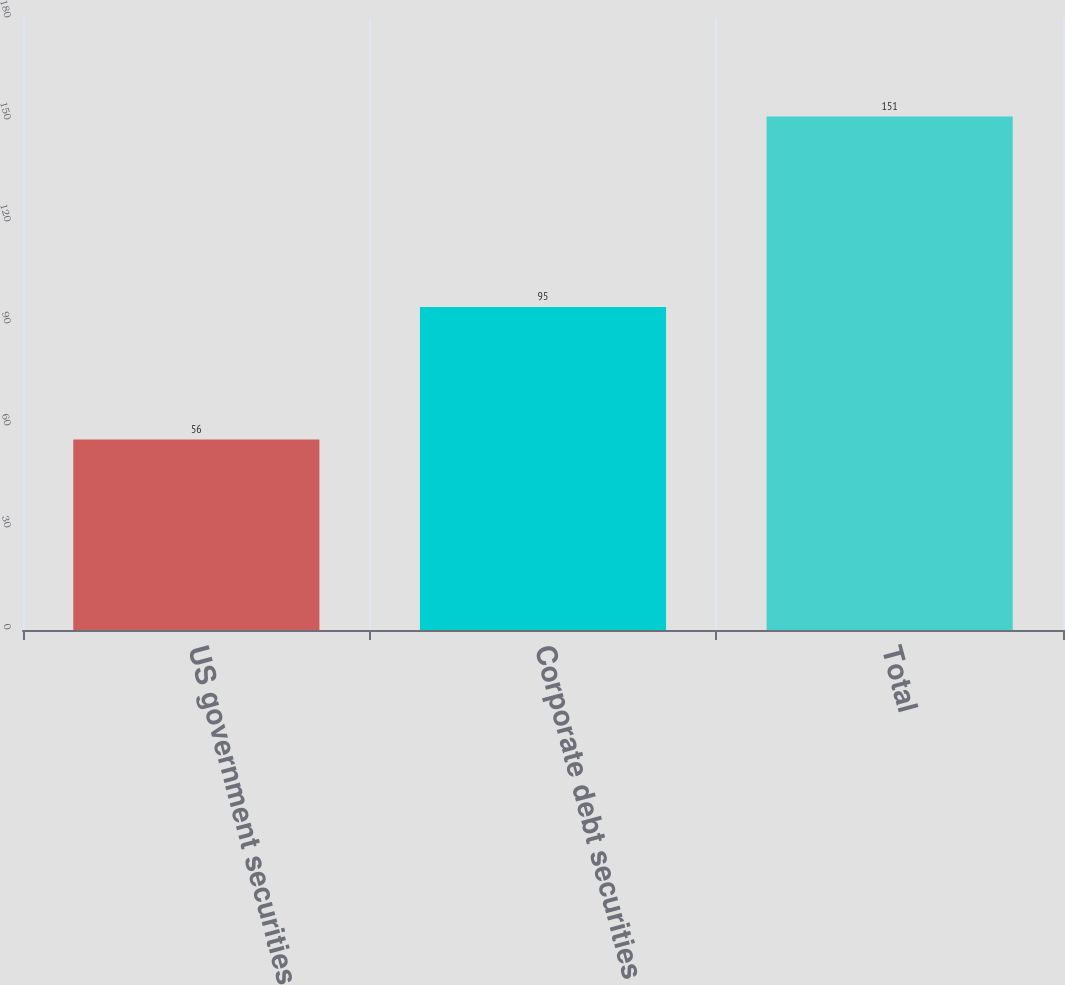Convert chart to OTSL. <chart><loc_0><loc_0><loc_500><loc_500><bar_chart><fcel>US government securities<fcel>Corporate debt securities<fcel>Total<nl><fcel>56<fcel>95<fcel>151<nl></chart> 